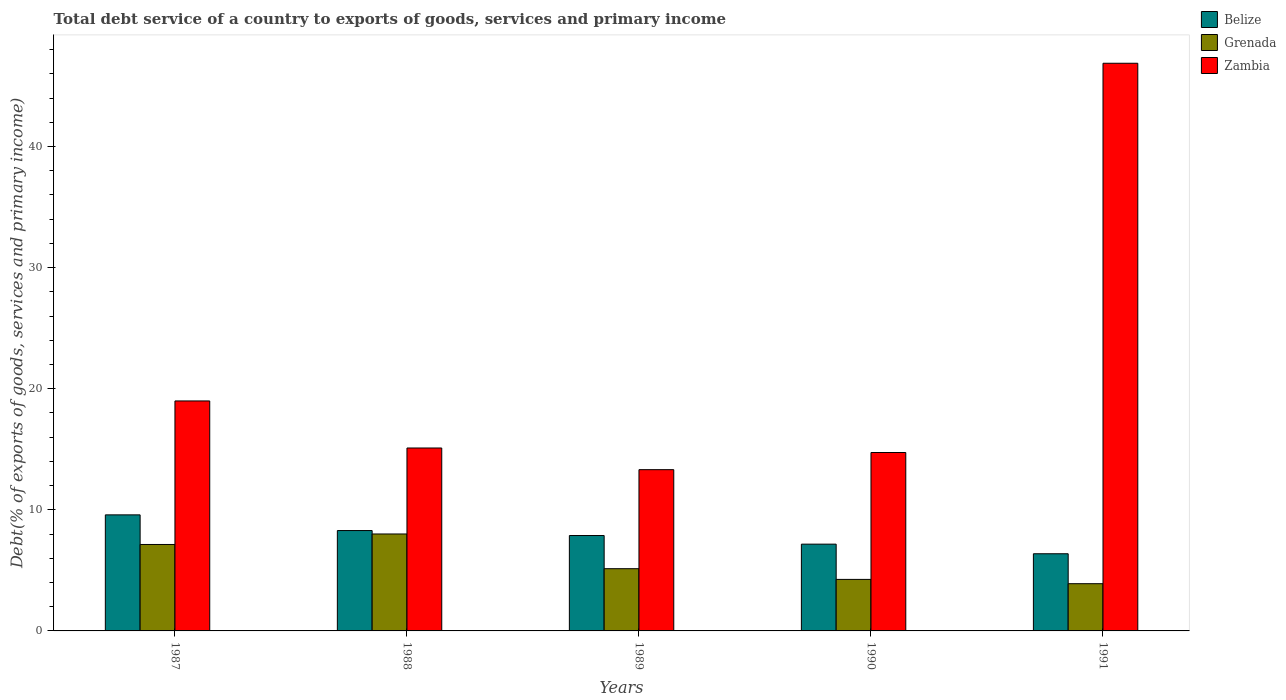How many different coloured bars are there?
Your response must be concise. 3. How many groups of bars are there?
Provide a succinct answer. 5. Are the number of bars on each tick of the X-axis equal?
Offer a very short reply. Yes. How many bars are there on the 2nd tick from the left?
Offer a terse response. 3. What is the total debt service in Grenada in 1991?
Give a very brief answer. 3.9. Across all years, what is the maximum total debt service in Zambia?
Your response must be concise. 46.88. Across all years, what is the minimum total debt service in Zambia?
Your answer should be very brief. 13.32. In which year was the total debt service in Zambia maximum?
Make the answer very short. 1991. What is the total total debt service in Belize in the graph?
Your answer should be compact. 39.29. What is the difference between the total debt service in Belize in 1987 and that in 1989?
Keep it short and to the point. 1.7. What is the difference between the total debt service in Zambia in 1987 and the total debt service in Belize in 1989?
Offer a terse response. 11.11. What is the average total debt service in Zambia per year?
Your answer should be very brief. 21.8. In the year 1988, what is the difference between the total debt service in Grenada and total debt service in Belize?
Make the answer very short. -0.28. In how many years, is the total debt service in Zambia greater than 32 %?
Your answer should be compact. 1. What is the ratio of the total debt service in Belize in 1988 to that in 1991?
Give a very brief answer. 1.3. Is the total debt service in Grenada in 1987 less than that in 1989?
Your response must be concise. No. What is the difference between the highest and the second highest total debt service in Zambia?
Your answer should be very brief. 27.88. What is the difference between the highest and the lowest total debt service in Belize?
Your response must be concise. 3.21. In how many years, is the total debt service in Belize greater than the average total debt service in Belize taken over all years?
Provide a short and direct response. 3. What does the 3rd bar from the left in 1989 represents?
Give a very brief answer. Zambia. What does the 2nd bar from the right in 1988 represents?
Your answer should be compact. Grenada. Are all the bars in the graph horizontal?
Keep it short and to the point. No. How many years are there in the graph?
Your answer should be very brief. 5. What is the difference between two consecutive major ticks on the Y-axis?
Your response must be concise. 10. Are the values on the major ticks of Y-axis written in scientific E-notation?
Your answer should be compact. No. Does the graph contain grids?
Provide a short and direct response. No. Where does the legend appear in the graph?
Provide a succinct answer. Top right. How many legend labels are there?
Keep it short and to the point. 3. What is the title of the graph?
Keep it short and to the point. Total debt service of a country to exports of goods, services and primary income. Does "Peru" appear as one of the legend labels in the graph?
Provide a short and direct response. No. What is the label or title of the X-axis?
Your answer should be compact. Years. What is the label or title of the Y-axis?
Keep it short and to the point. Debt(% of exports of goods, services and primary income). What is the Debt(% of exports of goods, services and primary income) of Belize in 1987?
Make the answer very short. 9.58. What is the Debt(% of exports of goods, services and primary income) of Grenada in 1987?
Your response must be concise. 7.14. What is the Debt(% of exports of goods, services and primary income) in Zambia in 1987?
Keep it short and to the point. 18.99. What is the Debt(% of exports of goods, services and primary income) of Belize in 1988?
Your answer should be very brief. 8.29. What is the Debt(% of exports of goods, services and primary income) in Grenada in 1988?
Provide a succinct answer. 8. What is the Debt(% of exports of goods, services and primary income) of Zambia in 1988?
Give a very brief answer. 15.11. What is the Debt(% of exports of goods, services and primary income) of Belize in 1989?
Provide a succinct answer. 7.88. What is the Debt(% of exports of goods, services and primary income) in Grenada in 1989?
Make the answer very short. 5.14. What is the Debt(% of exports of goods, services and primary income) of Zambia in 1989?
Provide a succinct answer. 13.32. What is the Debt(% of exports of goods, services and primary income) in Belize in 1990?
Provide a succinct answer. 7.17. What is the Debt(% of exports of goods, services and primary income) of Grenada in 1990?
Give a very brief answer. 4.25. What is the Debt(% of exports of goods, services and primary income) in Zambia in 1990?
Ensure brevity in your answer.  14.73. What is the Debt(% of exports of goods, services and primary income) in Belize in 1991?
Your answer should be compact. 6.37. What is the Debt(% of exports of goods, services and primary income) of Grenada in 1991?
Your answer should be compact. 3.9. What is the Debt(% of exports of goods, services and primary income) in Zambia in 1991?
Your response must be concise. 46.88. Across all years, what is the maximum Debt(% of exports of goods, services and primary income) in Belize?
Your response must be concise. 9.58. Across all years, what is the maximum Debt(% of exports of goods, services and primary income) in Grenada?
Offer a very short reply. 8. Across all years, what is the maximum Debt(% of exports of goods, services and primary income) in Zambia?
Give a very brief answer. 46.88. Across all years, what is the minimum Debt(% of exports of goods, services and primary income) of Belize?
Keep it short and to the point. 6.37. Across all years, what is the minimum Debt(% of exports of goods, services and primary income) of Grenada?
Make the answer very short. 3.9. Across all years, what is the minimum Debt(% of exports of goods, services and primary income) of Zambia?
Offer a terse response. 13.32. What is the total Debt(% of exports of goods, services and primary income) of Belize in the graph?
Provide a succinct answer. 39.29. What is the total Debt(% of exports of goods, services and primary income) in Grenada in the graph?
Give a very brief answer. 28.43. What is the total Debt(% of exports of goods, services and primary income) in Zambia in the graph?
Ensure brevity in your answer.  109.02. What is the difference between the Debt(% of exports of goods, services and primary income) of Belize in 1987 and that in 1988?
Offer a very short reply. 1.29. What is the difference between the Debt(% of exports of goods, services and primary income) of Grenada in 1987 and that in 1988?
Ensure brevity in your answer.  -0.87. What is the difference between the Debt(% of exports of goods, services and primary income) of Zambia in 1987 and that in 1988?
Offer a terse response. 3.89. What is the difference between the Debt(% of exports of goods, services and primary income) in Belize in 1987 and that in 1989?
Make the answer very short. 1.7. What is the difference between the Debt(% of exports of goods, services and primary income) of Grenada in 1987 and that in 1989?
Make the answer very short. 2. What is the difference between the Debt(% of exports of goods, services and primary income) in Zambia in 1987 and that in 1989?
Keep it short and to the point. 5.67. What is the difference between the Debt(% of exports of goods, services and primary income) of Belize in 1987 and that in 1990?
Keep it short and to the point. 2.42. What is the difference between the Debt(% of exports of goods, services and primary income) in Grenada in 1987 and that in 1990?
Provide a succinct answer. 2.88. What is the difference between the Debt(% of exports of goods, services and primary income) of Zambia in 1987 and that in 1990?
Offer a very short reply. 4.26. What is the difference between the Debt(% of exports of goods, services and primary income) in Belize in 1987 and that in 1991?
Your answer should be compact. 3.21. What is the difference between the Debt(% of exports of goods, services and primary income) of Grenada in 1987 and that in 1991?
Your response must be concise. 3.24. What is the difference between the Debt(% of exports of goods, services and primary income) in Zambia in 1987 and that in 1991?
Keep it short and to the point. -27.88. What is the difference between the Debt(% of exports of goods, services and primary income) in Belize in 1988 and that in 1989?
Offer a terse response. 0.41. What is the difference between the Debt(% of exports of goods, services and primary income) in Grenada in 1988 and that in 1989?
Give a very brief answer. 2.87. What is the difference between the Debt(% of exports of goods, services and primary income) in Zambia in 1988 and that in 1989?
Offer a terse response. 1.79. What is the difference between the Debt(% of exports of goods, services and primary income) of Belize in 1988 and that in 1990?
Make the answer very short. 1.12. What is the difference between the Debt(% of exports of goods, services and primary income) in Grenada in 1988 and that in 1990?
Provide a succinct answer. 3.75. What is the difference between the Debt(% of exports of goods, services and primary income) of Zambia in 1988 and that in 1990?
Provide a short and direct response. 0.37. What is the difference between the Debt(% of exports of goods, services and primary income) in Belize in 1988 and that in 1991?
Your response must be concise. 1.92. What is the difference between the Debt(% of exports of goods, services and primary income) of Grenada in 1988 and that in 1991?
Your answer should be very brief. 4.1. What is the difference between the Debt(% of exports of goods, services and primary income) in Zambia in 1988 and that in 1991?
Keep it short and to the point. -31.77. What is the difference between the Debt(% of exports of goods, services and primary income) in Belize in 1989 and that in 1990?
Give a very brief answer. 0.71. What is the difference between the Debt(% of exports of goods, services and primary income) in Grenada in 1989 and that in 1990?
Provide a succinct answer. 0.88. What is the difference between the Debt(% of exports of goods, services and primary income) in Zambia in 1989 and that in 1990?
Give a very brief answer. -1.42. What is the difference between the Debt(% of exports of goods, services and primary income) of Belize in 1989 and that in 1991?
Offer a terse response. 1.51. What is the difference between the Debt(% of exports of goods, services and primary income) in Grenada in 1989 and that in 1991?
Offer a terse response. 1.24. What is the difference between the Debt(% of exports of goods, services and primary income) of Zambia in 1989 and that in 1991?
Your answer should be compact. -33.56. What is the difference between the Debt(% of exports of goods, services and primary income) of Belize in 1990 and that in 1991?
Offer a very short reply. 0.79. What is the difference between the Debt(% of exports of goods, services and primary income) of Grenada in 1990 and that in 1991?
Provide a short and direct response. 0.35. What is the difference between the Debt(% of exports of goods, services and primary income) of Zambia in 1990 and that in 1991?
Provide a short and direct response. -32.14. What is the difference between the Debt(% of exports of goods, services and primary income) of Belize in 1987 and the Debt(% of exports of goods, services and primary income) of Grenada in 1988?
Give a very brief answer. 1.58. What is the difference between the Debt(% of exports of goods, services and primary income) of Belize in 1987 and the Debt(% of exports of goods, services and primary income) of Zambia in 1988?
Make the answer very short. -5.52. What is the difference between the Debt(% of exports of goods, services and primary income) of Grenada in 1987 and the Debt(% of exports of goods, services and primary income) of Zambia in 1988?
Give a very brief answer. -7.97. What is the difference between the Debt(% of exports of goods, services and primary income) in Belize in 1987 and the Debt(% of exports of goods, services and primary income) in Grenada in 1989?
Provide a short and direct response. 4.45. What is the difference between the Debt(% of exports of goods, services and primary income) in Belize in 1987 and the Debt(% of exports of goods, services and primary income) in Zambia in 1989?
Your response must be concise. -3.73. What is the difference between the Debt(% of exports of goods, services and primary income) in Grenada in 1987 and the Debt(% of exports of goods, services and primary income) in Zambia in 1989?
Your answer should be very brief. -6.18. What is the difference between the Debt(% of exports of goods, services and primary income) in Belize in 1987 and the Debt(% of exports of goods, services and primary income) in Grenada in 1990?
Your answer should be very brief. 5.33. What is the difference between the Debt(% of exports of goods, services and primary income) of Belize in 1987 and the Debt(% of exports of goods, services and primary income) of Zambia in 1990?
Keep it short and to the point. -5.15. What is the difference between the Debt(% of exports of goods, services and primary income) of Grenada in 1987 and the Debt(% of exports of goods, services and primary income) of Zambia in 1990?
Provide a short and direct response. -7.6. What is the difference between the Debt(% of exports of goods, services and primary income) of Belize in 1987 and the Debt(% of exports of goods, services and primary income) of Grenada in 1991?
Make the answer very short. 5.68. What is the difference between the Debt(% of exports of goods, services and primary income) in Belize in 1987 and the Debt(% of exports of goods, services and primary income) in Zambia in 1991?
Give a very brief answer. -37.29. What is the difference between the Debt(% of exports of goods, services and primary income) of Grenada in 1987 and the Debt(% of exports of goods, services and primary income) of Zambia in 1991?
Provide a succinct answer. -39.74. What is the difference between the Debt(% of exports of goods, services and primary income) of Belize in 1988 and the Debt(% of exports of goods, services and primary income) of Grenada in 1989?
Your response must be concise. 3.15. What is the difference between the Debt(% of exports of goods, services and primary income) in Belize in 1988 and the Debt(% of exports of goods, services and primary income) in Zambia in 1989?
Offer a very short reply. -5.03. What is the difference between the Debt(% of exports of goods, services and primary income) in Grenada in 1988 and the Debt(% of exports of goods, services and primary income) in Zambia in 1989?
Ensure brevity in your answer.  -5.31. What is the difference between the Debt(% of exports of goods, services and primary income) in Belize in 1988 and the Debt(% of exports of goods, services and primary income) in Grenada in 1990?
Give a very brief answer. 4.03. What is the difference between the Debt(% of exports of goods, services and primary income) in Belize in 1988 and the Debt(% of exports of goods, services and primary income) in Zambia in 1990?
Provide a short and direct response. -6.44. What is the difference between the Debt(% of exports of goods, services and primary income) in Grenada in 1988 and the Debt(% of exports of goods, services and primary income) in Zambia in 1990?
Your answer should be compact. -6.73. What is the difference between the Debt(% of exports of goods, services and primary income) of Belize in 1988 and the Debt(% of exports of goods, services and primary income) of Grenada in 1991?
Give a very brief answer. 4.39. What is the difference between the Debt(% of exports of goods, services and primary income) of Belize in 1988 and the Debt(% of exports of goods, services and primary income) of Zambia in 1991?
Your response must be concise. -38.59. What is the difference between the Debt(% of exports of goods, services and primary income) in Grenada in 1988 and the Debt(% of exports of goods, services and primary income) in Zambia in 1991?
Your response must be concise. -38.87. What is the difference between the Debt(% of exports of goods, services and primary income) in Belize in 1989 and the Debt(% of exports of goods, services and primary income) in Grenada in 1990?
Ensure brevity in your answer.  3.62. What is the difference between the Debt(% of exports of goods, services and primary income) in Belize in 1989 and the Debt(% of exports of goods, services and primary income) in Zambia in 1990?
Keep it short and to the point. -6.85. What is the difference between the Debt(% of exports of goods, services and primary income) of Grenada in 1989 and the Debt(% of exports of goods, services and primary income) of Zambia in 1990?
Your answer should be very brief. -9.6. What is the difference between the Debt(% of exports of goods, services and primary income) in Belize in 1989 and the Debt(% of exports of goods, services and primary income) in Grenada in 1991?
Offer a very short reply. 3.98. What is the difference between the Debt(% of exports of goods, services and primary income) in Belize in 1989 and the Debt(% of exports of goods, services and primary income) in Zambia in 1991?
Give a very brief answer. -39. What is the difference between the Debt(% of exports of goods, services and primary income) in Grenada in 1989 and the Debt(% of exports of goods, services and primary income) in Zambia in 1991?
Keep it short and to the point. -41.74. What is the difference between the Debt(% of exports of goods, services and primary income) in Belize in 1990 and the Debt(% of exports of goods, services and primary income) in Grenada in 1991?
Ensure brevity in your answer.  3.27. What is the difference between the Debt(% of exports of goods, services and primary income) of Belize in 1990 and the Debt(% of exports of goods, services and primary income) of Zambia in 1991?
Your answer should be very brief. -39.71. What is the difference between the Debt(% of exports of goods, services and primary income) of Grenada in 1990 and the Debt(% of exports of goods, services and primary income) of Zambia in 1991?
Make the answer very short. -42.62. What is the average Debt(% of exports of goods, services and primary income) of Belize per year?
Make the answer very short. 7.86. What is the average Debt(% of exports of goods, services and primary income) of Grenada per year?
Provide a short and direct response. 5.69. What is the average Debt(% of exports of goods, services and primary income) in Zambia per year?
Offer a terse response. 21.8. In the year 1987, what is the difference between the Debt(% of exports of goods, services and primary income) of Belize and Debt(% of exports of goods, services and primary income) of Grenada?
Give a very brief answer. 2.44. In the year 1987, what is the difference between the Debt(% of exports of goods, services and primary income) in Belize and Debt(% of exports of goods, services and primary income) in Zambia?
Ensure brevity in your answer.  -9.41. In the year 1987, what is the difference between the Debt(% of exports of goods, services and primary income) in Grenada and Debt(% of exports of goods, services and primary income) in Zambia?
Provide a succinct answer. -11.85. In the year 1988, what is the difference between the Debt(% of exports of goods, services and primary income) of Belize and Debt(% of exports of goods, services and primary income) of Grenada?
Ensure brevity in your answer.  0.28. In the year 1988, what is the difference between the Debt(% of exports of goods, services and primary income) of Belize and Debt(% of exports of goods, services and primary income) of Zambia?
Ensure brevity in your answer.  -6.82. In the year 1988, what is the difference between the Debt(% of exports of goods, services and primary income) in Grenada and Debt(% of exports of goods, services and primary income) in Zambia?
Your response must be concise. -7.1. In the year 1989, what is the difference between the Debt(% of exports of goods, services and primary income) of Belize and Debt(% of exports of goods, services and primary income) of Grenada?
Make the answer very short. 2.74. In the year 1989, what is the difference between the Debt(% of exports of goods, services and primary income) of Belize and Debt(% of exports of goods, services and primary income) of Zambia?
Offer a terse response. -5.44. In the year 1989, what is the difference between the Debt(% of exports of goods, services and primary income) of Grenada and Debt(% of exports of goods, services and primary income) of Zambia?
Give a very brief answer. -8.18. In the year 1990, what is the difference between the Debt(% of exports of goods, services and primary income) in Belize and Debt(% of exports of goods, services and primary income) in Grenada?
Provide a short and direct response. 2.91. In the year 1990, what is the difference between the Debt(% of exports of goods, services and primary income) of Belize and Debt(% of exports of goods, services and primary income) of Zambia?
Make the answer very short. -7.57. In the year 1990, what is the difference between the Debt(% of exports of goods, services and primary income) of Grenada and Debt(% of exports of goods, services and primary income) of Zambia?
Provide a short and direct response. -10.48. In the year 1991, what is the difference between the Debt(% of exports of goods, services and primary income) of Belize and Debt(% of exports of goods, services and primary income) of Grenada?
Provide a succinct answer. 2.47. In the year 1991, what is the difference between the Debt(% of exports of goods, services and primary income) in Belize and Debt(% of exports of goods, services and primary income) in Zambia?
Offer a very short reply. -40.5. In the year 1991, what is the difference between the Debt(% of exports of goods, services and primary income) in Grenada and Debt(% of exports of goods, services and primary income) in Zambia?
Offer a terse response. -42.98. What is the ratio of the Debt(% of exports of goods, services and primary income) of Belize in 1987 to that in 1988?
Ensure brevity in your answer.  1.16. What is the ratio of the Debt(% of exports of goods, services and primary income) in Grenada in 1987 to that in 1988?
Ensure brevity in your answer.  0.89. What is the ratio of the Debt(% of exports of goods, services and primary income) in Zambia in 1987 to that in 1988?
Make the answer very short. 1.26. What is the ratio of the Debt(% of exports of goods, services and primary income) in Belize in 1987 to that in 1989?
Offer a very short reply. 1.22. What is the ratio of the Debt(% of exports of goods, services and primary income) in Grenada in 1987 to that in 1989?
Your response must be concise. 1.39. What is the ratio of the Debt(% of exports of goods, services and primary income) of Zambia in 1987 to that in 1989?
Keep it short and to the point. 1.43. What is the ratio of the Debt(% of exports of goods, services and primary income) in Belize in 1987 to that in 1990?
Offer a terse response. 1.34. What is the ratio of the Debt(% of exports of goods, services and primary income) of Grenada in 1987 to that in 1990?
Your answer should be compact. 1.68. What is the ratio of the Debt(% of exports of goods, services and primary income) in Zambia in 1987 to that in 1990?
Offer a very short reply. 1.29. What is the ratio of the Debt(% of exports of goods, services and primary income) of Belize in 1987 to that in 1991?
Make the answer very short. 1.5. What is the ratio of the Debt(% of exports of goods, services and primary income) in Grenada in 1987 to that in 1991?
Offer a very short reply. 1.83. What is the ratio of the Debt(% of exports of goods, services and primary income) in Zambia in 1987 to that in 1991?
Your response must be concise. 0.41. What is the ratio of the Debt(% of exports of goods, services and primary income) of Belize in 1988 to that in 1989?
Provide a short and direct response. 1.05. What is the ratio of the Debt(% of exports of goods, services and primary income) of Grenada in 1988 to that in 1989?
Your response must be concise. 1.56. What is the ratio of the Debt(% of exports of goods, services and primary income) in Zambia in 1988 to that in 1989?
Provide a short and direct response. 1.13. What is the ratio of the Debt(% of exports of goods, services and primary income) in Belize in 1988 to that in 1990?
Offer a very short reply. 1.16. What is the ratio of the Debt(% of exports of goods, services and primary income) of Grenada in 1988 to that in 1990?
Your answer should be compact. 1.88. What is the ratio of the Debt(% of exports of goods, services and primary income) of Zambia in 1988 to that in 1990?
Your answer should be very brief. 1.03. What is the ratio of the Debt(% of exports of goods, services and primary income) in Belize in 1988 to that in 1991?
Give a very brief answer. 1.3. What is the ratio of the Debt(% of exports of goods, services and primary income) in Grenada in 1988 to that in 1991?
Provide a short and direct response. 2.05. What is the ratio of the Debt(% of exports of goods, services and primary income) in Zambia in 1988 to that in 1991?
Offer a very short reply. 0.32. What is the ratio of the Debt(% of exports of goods, services and primary income) in Belize in 1989 to that in 1990?
Provide a succinct answer. 1.1. What is the ratio of the Debt(% of exports of goods, services and primary income) in Grenada in 1989 to that in 1990?
Ensure brevity in your answer.  1.21. What is the ratio of the Debt(% of exports of goods, services and primary income) in Zambia in 1989 to that in 1990?
Offer a terse response. 0.9. What is the ratio of the Debt(% of exports of goods, services and primary income) in Belize in 1989 to that in 1991?
Ensure brevity in your answer.  1.24. What is the ratio of the Debt(% of exports of goods, services and primary income) in Grenada in 1989 to that in 1991?
Provide a short and direct response. 1.32. What is the ratio of the Debt(% of exports of goods, services and primary income) of Zambia in 1989 to that in 1991?
Provide a short and direct response. 0.28. What is the ratio of the Debt(% of exports of goods, services and primary income) in Belize in 1990 to that in 1991?
Your response must be concise. 1.12. What is the ratio of the Debt(% of exports of goods, services and primary income) of Grenada in 1990 to that in 1991?
Provide a short and direct response. 1.09. What is the ratio of the Debt(% of exports of goods, services and primary income) of Zambia in 1990 to that in 1991?
Give a very brief answer. 0.31. What is the difference between the highest and the second highest Debt(% of exports of goods, services and primary income) of Belize?
Offer a terse response. 1.29. What is the difference between the highest and the second highest Debt(% of exports of goods, services and primary income) of Grenada?
Provide a short and direct response. 0.87. What is the difference between the highest and the second highest Debt(% of exports of goods, services and primary income) in Zambia?
Ensure brevity in your answer.  27.88. What is the difference between the highest and the lowest Debt(% of exports of goods, services and primary income) in Belize?
Your response must be concise. 3.21. What is the difference between the highest and the lowest Debt(% of exports of goods, services and primary income) of Grenada?
Provide a short and direct response. 4.1. What is the difference between the highest and the lowest Debt(% of exports of goods, services and primary income) of Zambia?
Provide a short and direct response. 33.56. 